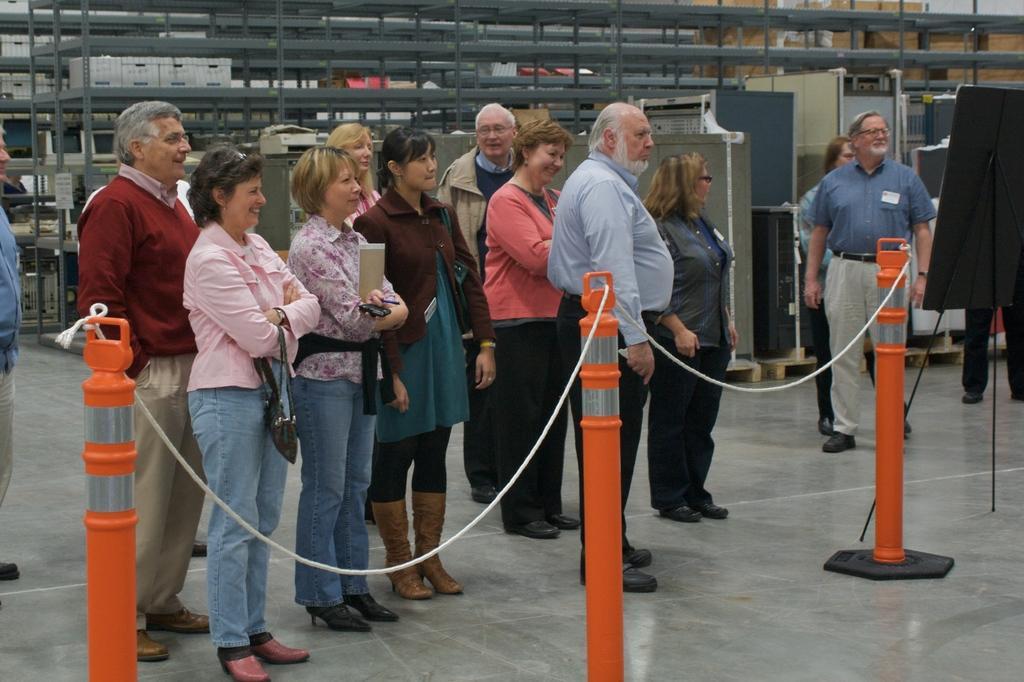Describe this image in one or two sentences. In this image in the front there is a fence. In the center there are persons standing and smiling. In the background there are stands and on the right side there is a board which is on the stand. 